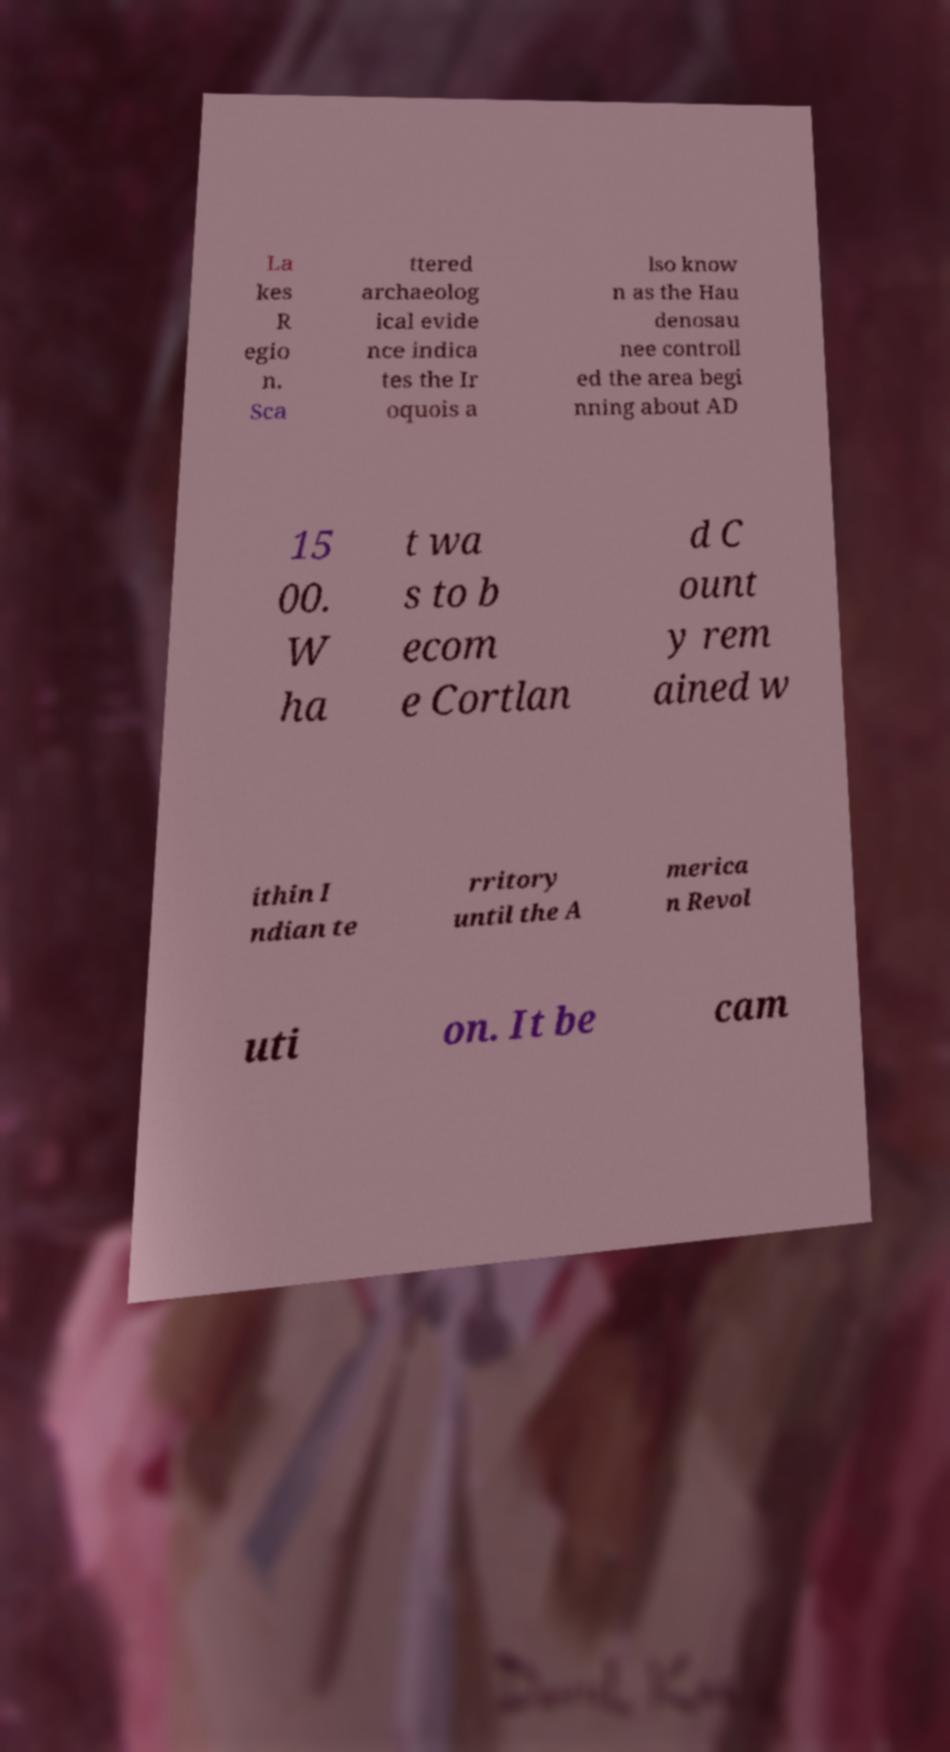Can you read and provide the text displayed in the image?This photo seems to have some interesting text. Can you extract and type it out for me? La kes R egio n. Sca ttered archaeolog ical evide nce indica tes the Ir oquois a lso know n as the Hau denosau nee controll ed the area begi nning about AD 15 00. W ha t wa s to b ecom e Cortlan d C ount y rem ained w ithin I ndian te rritory until the A merica n Revol uti on. It be cam 